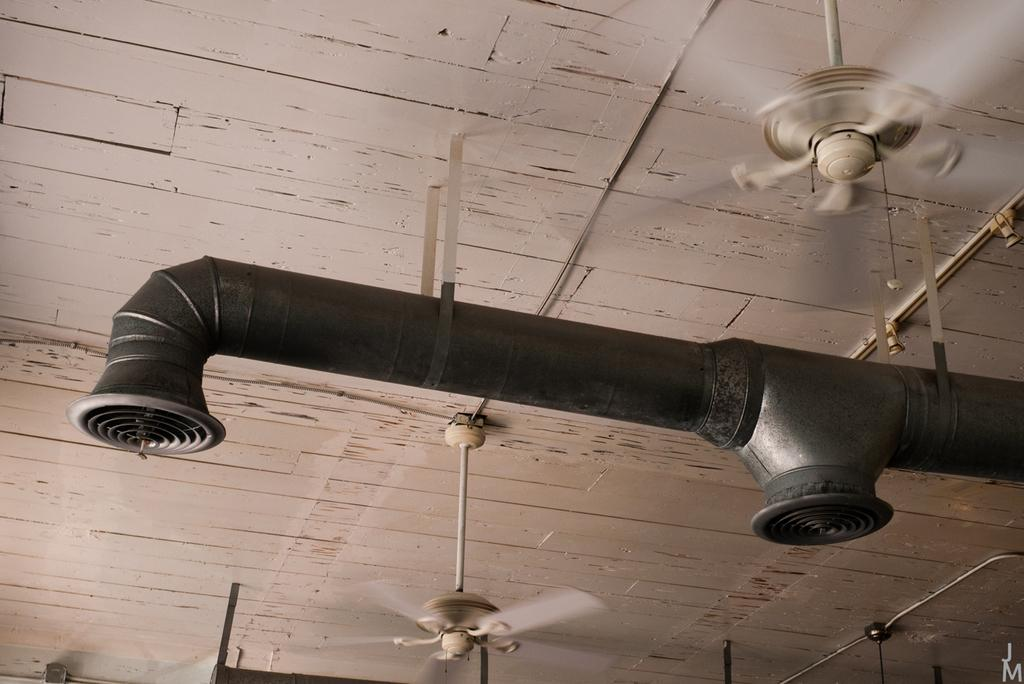What is located at the front of the image? There is a pipe in the front of the image. What can be seen at the top of the image? There are fans on the top of the image. What type of fruit is being used to give a haircut in the image? There is no fruit or haircut present in the image; it features a pipe and fans. How does the jelly contribute to the functioning of the fans in the image? There is no jelly present in the image, and therefore it does not contribute to the functioning of the fans. 